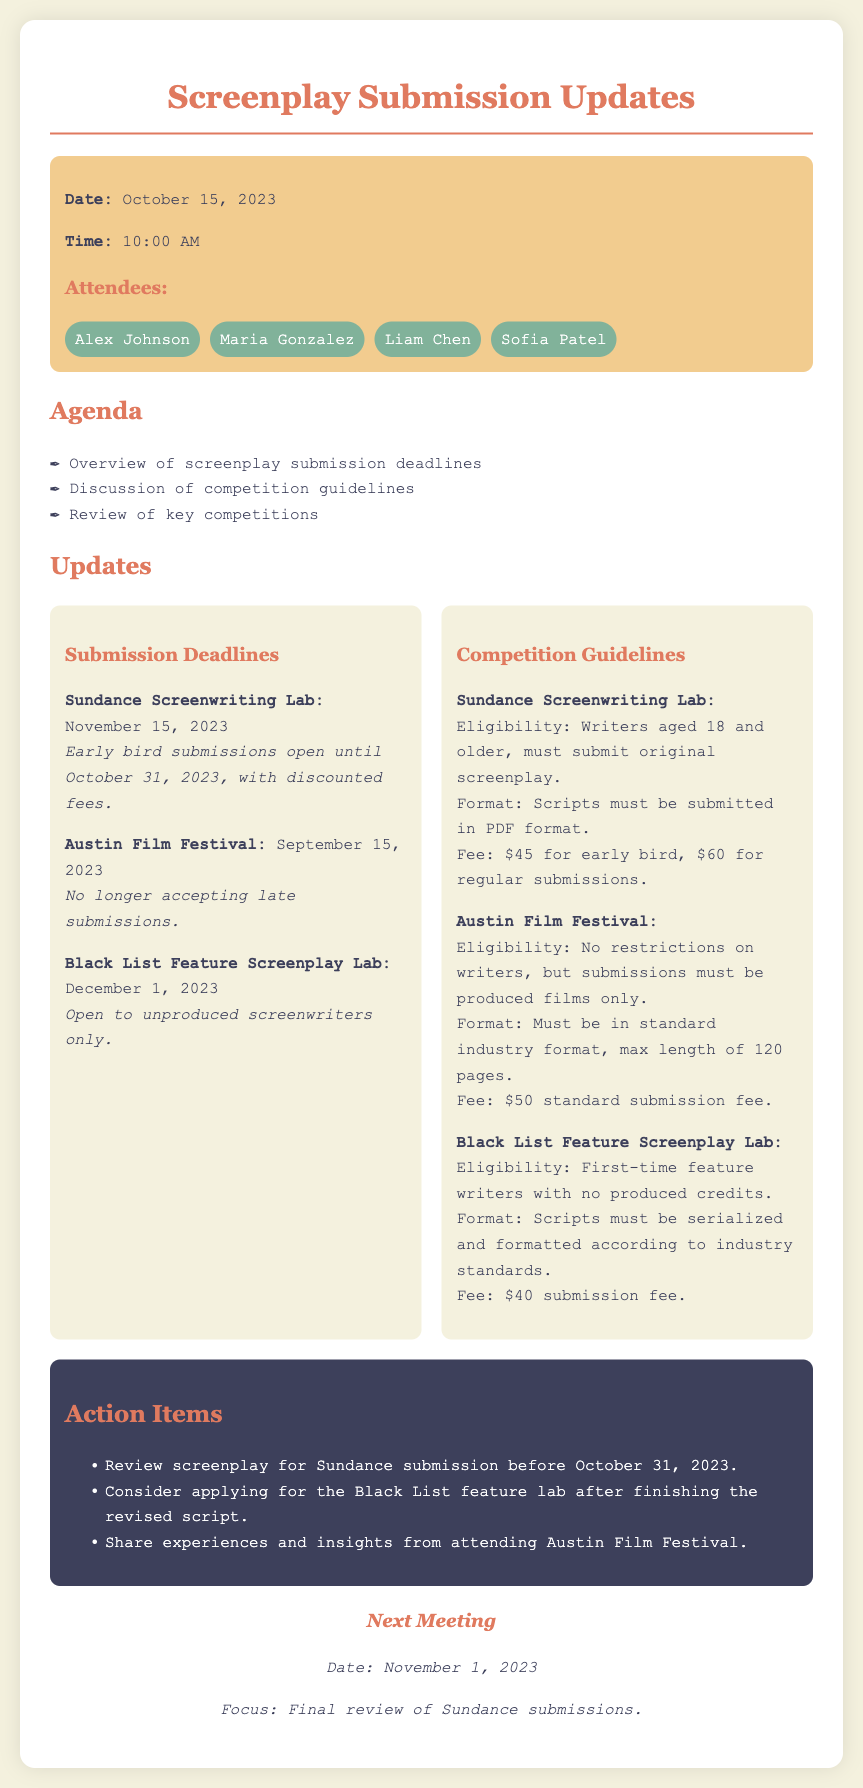what is the date of the meeting? The date of the meeting is mentioned in the meta-info section of the document.
Answer: October 15, 2023 what is the submission deadline for the Sundance Screenwriting Lab? The submission deadline for Sundance is listed under the updates section.
Answer: November 15, 2023 what is the fee for regular submissions to the Sundance Screenwriting Lab? The fee is specified in the competition guidelines section.
Answer: $60 who are the attendees of the meeting? The attendees are listed in the meta-info section of the document.
Answer: Alex Johnson, Maria Gonzalez, Liam Chen, Sofia Patel what is the eligibility requirement for the Black List Feature Screenplay Lab? The eligibility is included in the competition guidelines for the Black List lab.
Answer: First-time feature writers with no produced credits which competition does not accept late submissions? This information can be found within the updates section under Austin Film Festival.
Answer: Austin Film Festival what is the next meeting date? The next meeting date is provided in the next meeting section.
Answer: November 1, 2023 how much is the early bird submission fee for the Sundance Screenwriting Lab? The fee amount is specified in the competition guidelines section.
Answer: $45 what is the maximum length for submissions to the Austin Film Festival? This information is detailed in the competition guidelines for that festival.
Answer: 120 pages 